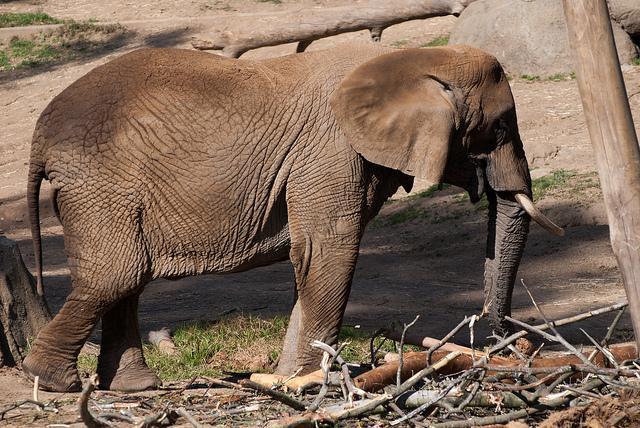How many of its tusks are visible?
Give a very brief answer. 1. 